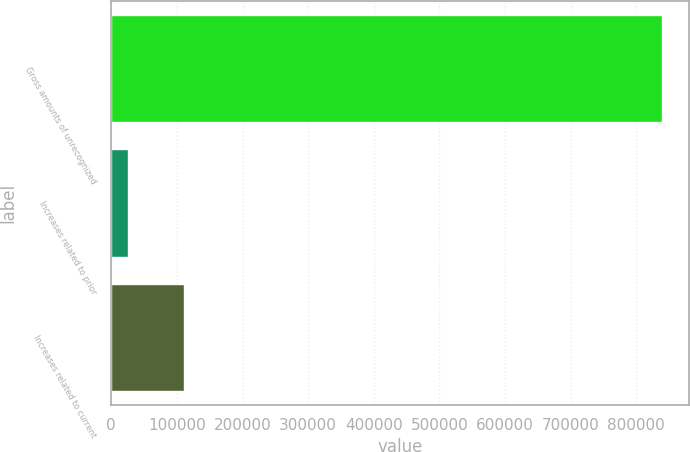<chart> <loc_0><loc_0><loc_500><loc_500><bar_chart><fcel>Gross amounts of unrecognized<fcel>Increases related to prior<fcel>Increases related to current<nl><fcel>838616<fcel>26247<fcel>110995<nl></chart> 